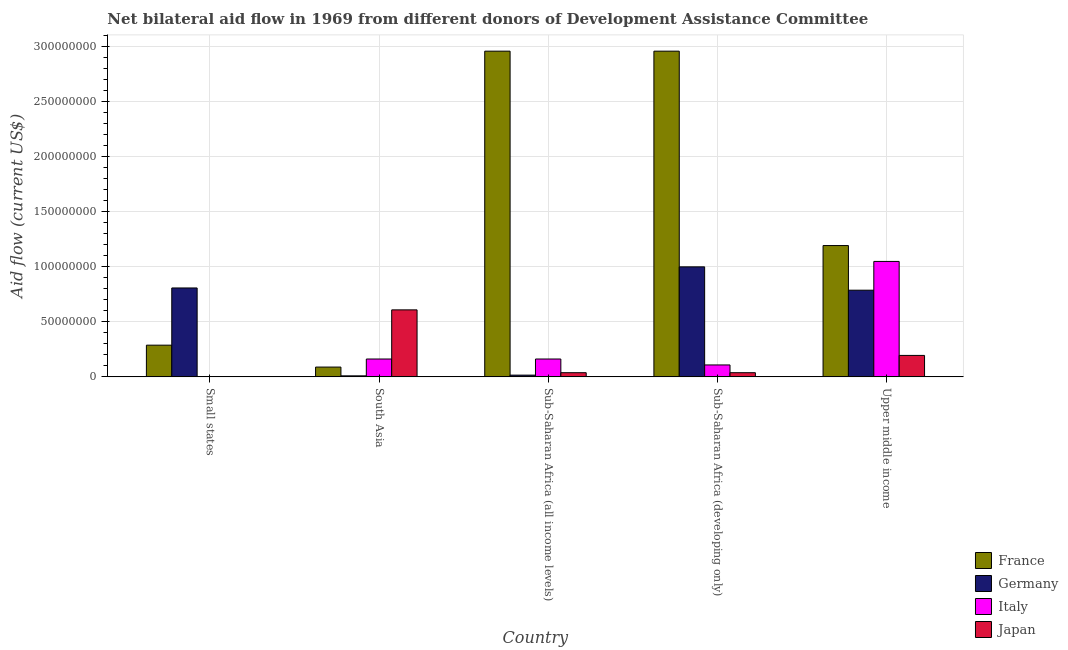How many groups of bars are there?
Ensure brevity in your answer.  5. Are the number of bars on each tick of the X-axis equal?
Your response must be concise. Yes. How many bars are there on the 4th tick from the left?
Give a very brief answer. 4. How many bars are there on the 2nd tick from the right?
Keep it short and to the point. 4. What is the label of the 2nd group of bars from the left?
Your answer should be compact. South Asia. In how many cases, is the number of bars for a given country not equal to the number of legend labels?
Your response must be concise. 0. What is the amount of aid given by germany in Small states?
Ensure brevity in your answer.  8.08e+07. Across all countries, what is the maximum amount of aid given by france?
Offer a very short reply. 2.96e+08. Across all countries, what is the minimum amount of aid given by france?
Your answer should be compact. 8.90e+06. In which country was the amount of aid given by italy maximum?
Make the answer very short. Upper middle income. In which country was the amount of aid given by japan minimum?
Provide a succinct answer. Small states. What is the total amount of aid given by france in the graph?
Provide a short and direct response. 7.49e+08. What is the difference between the amount of aid given by italy in Sub-Saharan Africa (developing only) and that in Upper middle income?
Offer a very short reply. -9.40e+07. What is the difference between the amount of aid given by japan in Small states and the amount of aid given by germany in Sub-Saharan Africa (all income levels)?
Provide a succinct answer. -1.45e+06. What is the average amount of aid given by germany per country?
Your answer should be compact. 5.24e+07. What is the difference between the amount of aid given by japan and amount of aid given by italy in Upper middle income?
Provide a short and direct response. -8.54e+07. What is the ratio of the amount of aid given by germany in Sub-Saharan Africa (all income levels) to that in Sub-Saharan Africa (developing only)?
Give a very brief answer. 0.02. Is the amount of aid given by germany in Sub-Saharan Africa (developing only) less than that in Upper middle income?
Your answer should be compact. No. What is the difference between the highest and the second highest amount of aid given by germany?
Give a very brief answer. 1.92e+07. What is the difference between the highest and the lowest amount of aid given by italy?
Your response must be concise. 1.05e+08. In how many countries, is the amount of aid given by japan greater than the average amount of aid given by japan taken over all countries?
Make the answer very short. 2. Is the sum of the amount of aid given by japan in Sub-Saharan Africa (all income levels) and Upper middle income greater than the maximum amount of aid given by italy across all countries?
Your response must be concise. No. Are the values on the major ticks of Y-axis written in scientific E-notation?
Your response must be concise. No. Does the graph contain any zero values?
Make the answer very short. No. Where does the legend appear in the graph?
Offer a terse response. Bottom right. How many legend labels are there?
Give a very brief answer. 4. What is the title of the graph?
Give a very brief answer. Net bilateral aid flow in 1969 from different donors of Development Assistance Committee. Does "Revenue mobilization" appear as one of the legend labels in the graph?
Make the answer very short. No. What is the label or title of the X-axis?
Your answer should be compact. Country. What is the Aid flow (current US$) in France in Small states?
Give a very brief answer. 2.88e+07. What is the Aid flow (current US$) of Germany in Small states?
Give a very brief answer. 8.08e+07. What is the Aid flow (current US$) of Italy in Small states?
Your answer should be compact. 9.00e+04. What is the Aid flow (current US$) of France in South Asia?
Offer a terse response. 8.90e+06. What is the Aid flow (current US$) in Germany in South Asia?
Offer a terse response. 9.20e+05. What is the Aid flow (current US$) of Italy in South Asia?
Keep it short and to the point. 1.62e+07. What is the Aid flow (current US$) of Japan in South Asia?
Give a very brief answer. 6.09e+07. What is the Aid flow (current US$) in France in Sub-Saharan Africa (all income levels)?
Your answer should be very brief. 2.96e+08. What is the Aid flow (current US$) of Germany in Sub-Saharan Africa (all income levels)?
Make the answer very short. 1.58e+06. What is the Aid flow (current US$) in Italy in Sub-Saharan Africa (all income levels)?
Offer a terse response. 1.62e+07. What is the Aid flow (current US$) of Japan in Sub-Saharan Africa (all income levels)?
Your response must be concise. 3.79e+06. What is the Aid flow (current US$) of France in Sub-Saharan Africa (developing only)?
Offer a very short reply. 2.96e+08. What is the Aid flow (current US$) in Germany in Sub-Saharan Africa (developing only)?
Offer a terse response. 1.00e+08. What is the Aid flow (current US$) of Italy in Sub-Saharan Africa (developing only)?
Offer a terse response. 1.08e+07. What is the Aid flow (current US$) in Japan in Sub-Saharan Africa (developing only)?
Offer a very short reply. 3.79e+06. What is the Aid flow (current US$) in France in Upper middle income?
Provide a short and direct response. 1.19e+08. What is the Aid flow (current US$) of Germany in Upper middle income?
Keep it short and to the point. 7.88e+07. What is the Aid flow (current US$) of Italy in Upper middle income?
Provide a short and direct response. 1.05e+08. What is the Aid flow (current US$) in Japan in Upper middle income?
Offer a terse response. 1.95e+07. Across all countries, what is the maximum Aid flow (current US$) of France?
Offer a terse response. 2.96e+08. Across all countries, what is the maximum Aid flow (current US$) of Germany?
Offer a very short reply. 1.00e+08. Across all countries, what is the maximum Aid flow (current US$) in Italy?
Give a very brief answer. 1.05e+08. Across all countries, what is the maximum Aid flow (current US$) in Japan?
Offer a terse response. 6.09e+07. Across all countries, what is the minimum Aid flow (current US$) in France?
Offer a terse response. 8.90e+06. Across all countries, what is the minimum Aid flow (current US$) in Germany?
Make the answer very short. 9.20e+05. Across all countries, what is the minimum Aid flow (current US$) of Italy?
Your answer should be very brief. 9.00e+04. Across all countries, what is the minimum Aid flow (current US$) in Japan?
Offer a terse response. 1.30e+05. What is the total Aid flow (current US$) in France in the graph?
Your response must be concise. 7.49e+08. What is the total Aid flow (current US$) in Germany in the graph?
Give a very brief answer. 2.62e+08. What is the total Aid flow (current US$) in Italy in the graph?
Your response must be concise. 1.48e+08. What is the total Aid flow (current US$) of Japan in the graph?
Your answer should be compact. 8.81e+07. What is the difference between the Aid flow (current US$) in France in Small states and that in South Asia?
Your response must be concise. 1.99e+07. What is the difference between the Aid flow (current US$) of Germany in Small states and that in South Asia?
Give a very brief answer. 7.98e+07. What is the difference between the Aid flow (current US$) of Italy in Small states and that in South Asia?
Your answer should be compact. -1.61e+07. What is the difference between the Aid flow (current US$) in Japan in Small states and that in South Asia?
Your response must be concise. -6.07e+07. What is the difference between the Aid flow (current US$) in France in Small states and that in Sub-Saharan Africa (all income levels)?
Provide a succinct answer. -2.67e+08. What is the difference between the Aid flow (current US$) of Germany in Small states and that in Sub-Saharan Africa (all income levels)?
Provide a short and direct response. 7.92e+07. What is the difference between the Aid flow (current US$) in Italy in Small states and that in Sub-Saharan Africa (all income levels)?
Give a very brief answer. -1.61e+07. What is the difference between the Aid flow (current US$) of Japan in Small states and that in Sub-Saharan Africa (all income levels)?
Your answer should be compact. -3.66e+06. What is the difference between the Aid flow (current US$) in France in Small states and that in Sub-Saharan Africa (developing only)?
Offer a very short reply. -2.67e+08. What is the difference between the Aid flow (current US$) of Germany in Small states and that in Sub-Saharan Africa (developing only)?
Offer a terse response. -1.92e+07. What is the difference between the Aid flow (current US$) of Italy in Small states and that in Sub-Saharan Africa (developing only)?
Provide a succinct answer. -1.07e+07. What is the difference between the Aid flow (current US$) in Japan in Small states and that in Sub-Saharan Africa (developing only)?
Provide a succinct answer. -3.66e+06. What is the difference between the Aid flow (current US$) in France in Small states and that in Upper middle income?
Provide a succinct answer. -9.05e+07. What is the difference between the Aid flow (current US$) of Germany in Small states and that in Upper middle income?
Ensure brevity in your answer.  2.02e+06. What is the difference between the Aid flow (current US$) of Italy in Small states and that in Upper middle income?
Give a very brief answer. -1.05e+08. What is the difference between the Aid flow (current US$) in Japan in Small states and that in Upper middle income?
Your answer should be compact. -1.94e+07. What is the difference between the Aid flow (current US$) of France in South Asia and that in Sub-Saharan Africa (all income levels)?
Give a very brief answer. -2.87e+08. What is the difference between the Aid flow (current US$) in Germany in South Asia and that in Sub-Saharan Africa (all income levels)?
Provide a short and direct response. -6.60e+05. What is the difference between the Aid flow (current US$) in Japan in South Asia and that in Sub-Saharan Africa (all income levels)?
Make the answer very short. 5.71e+07. What is the difference between the Aid flow (current US$) of France in South Asia and that in Sub-Saharan Africa (developing only)?
Your answer should be very brief. -2.87e+08. What is the difference between the Aid flow (current US$) of Germany in South Asia and that in Sub-Saharan Africa (developing only)?
Your response must be concise. -9.90e+07. What is the difference between the Aid flow (current US$) in Italy in South Asia and that in Sub-Saharan Africa (developing only)?
Your answer should be very brief. 5.40e+06. What is the difference between the Aid flow (current US$) of Japan in South Asia and that in Sub-Saharan Africa (developing only)?
Give a very brief answer. 5.71e+07. What is the difference between the Aid flow (current US$) of France in South Asia and that in Upper middle income?
Keep it short and to the point. -1.10e+08. What is the difference between the Aid flow (current US$) of Germany in South Asia and that in Upper middle income?
Offer a terse response. -7.78e+07. What is the difference between the Aid flow (current US$) in Italy in South Asia and that in Upper middle income?
Provide a short and direct response. -8.86e+07. What is the difference between the Aid flow (current US$) of Japan in South Asia and that in Upper middle income?
Your answer should be compact. 4.14e+07. What is the difference between the Aid flow (current US$) in Germany in Sub-Saharan Africa (all income levels) and that in Sub-Saharan Africa (developing only)?
Offer a very short reply. -9.84e+07. What is the difference between the Aid flow (current US$) of Italy in Sub-Saharan Africa (all income levels) and that in Sub-Saharan Africa (developing only)?
Ensure brevity in your answer.  5.40e+06. What is the difference between the Aid flow (current US$) in Japan in Sub-Saharan Africa (all income levels) and that in Sub-Saharan Africa (developing only)?
Provide a succinct answer. 0. What is the difference between the Aid flow (current US$) in France in Sub-Saharan Africa (all income levels) and that in Upper middle income?
Make the answer very short. 1.77e+08. What is the difference between the Aid flow (current US$) of Germany in Sub-Saharan Africa (all income levels) and that in Upper middle income?
Give a very brief answer. -7.72e+07. What is the difference between the Aid flow (current US$) of Italy in Sub-Saharan Africa (all income levels) and that in Upper middle income?
Your answer should be very brief. -8.86e+07. What is the difference between the Aid flow (current US$) of Japan in Sub-Saharan Africa (all income levels) and that in Upper middle income?
Provide a succinct answer. -1.57e+07. What is the difference between the Aid flow (current US$) of France in Sub-Saharan Africa (developing only) and that in Upper middle income?
Ensure brevity in your answer.  1.77e+08. What is the difference between the Aid flow (current US$) of Germany in Sub-Saharan Africa (developing only) and that in Upper middle income?
Ensure brevity in your answer.  2.12e+07. What is the difference between the Aid flow (current US$) in Italy in Sub-Saharan Africa (developing only) and that in Upper middle income?
Your answer should be very brief. -9.40e+07. What is the difference between the Aid flow (current US$) in Japan in Sub-Saharan Africa (developing only) and that in Upper middle income?
Make the answer very short. -1.57e+07. What is the difference between the Aid flow (current US$) in France in Small states and the Aid flow (current US$) in Germany in South Asia?
Offer a terse response. 2.79e+07. What is the difference between the Aid flow (current US$) of France in Small states and the Aid flow (current US$) of Italy in South Asia?
Make the answer very short. 1.26e+07. What is the difference between the Aid flow (current US$) of France in Small states and the Aid flow (current US$) of Japan in South Asia?
Give a very brief answer. -3.21e+07. What is the difference between the Aid flow (current US$) of Germany in Small states and the Aid flow (current US$) of Italy in South Asia?
Provide a succinct answer. 6.45e+07. What is the difference between the Aid flow (current US$) of Germany in Small states and the Aid flow (current US$) of Japan in South Asia?
Ensure brevity in your answer.  1.99e+07. What is the difference between the Aid flow (current US$) of Italy in Small states and the Aid flow (current US$) of Japan in South Asia?
Keep it short and to the point. -6.08e+07. What is the difference between the Aid flow (current US$) in France in Small states and the Aid flow (current US$) in Germany in Sub-Saharan Africa (all income levels)?
Keep it short and to the point. 2.72e+07. What is the difference between the Aid flow (current US$) of France in Small states and the Aid flow (current US$) of Italy in Sub-Saharan Africa (all income levels)?
Your answer should be very brief. 1.26e+07. What is the difference between the Aid flow (current US$) in France in Small states and the Aid flow (current US$) in Japan in Sub-Saharan Africa (all income levels)?
Ensure brevity in your answer.  2.50e+07. What is the difference between the Aid flow (current US$) of Germany in Small states and the Aid flow (current US$) of Italy in Sub-Saharan Africa (all income levels)?
Offer a terse response. 6.45e+07. What is the difference between the Aid flow (current US$) of Germany in Small states and the Aid flow (current US$) of Japan in Sub-Saharan Africa (all income levels)?
Give a very brief answer. 7.70e+07. What is the difference between the Aid flow (current US$) in Italy in Small states and the Aid flow (current US$) in Japan in Sub-Saharan Africa (all income levels)?
Your answer should be very brief. -3.70e+06. What is the difference between the Aid flow (current US$) in France in Small states and the Aid flow (current US$) in Germany in Sub-Saharan Africa (developing only)?
Your answer should be very brief. -7.12e+07. What is the difference between the Aid flow (current US$) of France in Small states and the Aid flow (current US$) of Italy in Sub-Saharan Africa (developing only)?
Make the answer very short. 1.80e+07. What is the difference between the Aid flow (current US$) of France in Small states and the Aid flow (current US$) of Japan in Sub-Saharan Africa (developing only)?
Make the answer very short. 2.50e+07. What is the difference between the Aid flow (current US$) in Germany in Small states and the Aid flow (current US$) in Italy in Sub-Saharan Africa (developing only)?
Provide a succinct answer. 6.99e+07. What is the difference between the Aid flow (current US$) in Germany in Small states and the Aid flow (current US$) in Japan in Sub-Saharan Africa (developing only)?
Give a very brief answer. 7.70e+07. What is the difference between the Aid flow (current US$) of Italy in Small states and the Aid flow (current US$) of Japan in Sub-Saharan Africa (developing only)?
Ensure brevity in your answer.  -3.70e+06. What is the difference between the Aid flow (current US$) of France in Small states and the Aid flow (current US$) of Germany in Upper middle income?
Make the answer very short. -5.00e+07. What is the difference between the Aid flow (current US$) in France in Small states and the Aid flow (current US$) in Italy in Upper middle income?
Keep it short and to the point. -7.61e+07. What is the difference between the Aid flow (current US$) in France in Small states and the Aid flow (current US$) in Japan in Upper middle income?
Your answer should be compact. 9.31e+06. What is the difference between the Aid flow (current US$) in Germany in Small states and the Aid flow (current US$) in Italy in Upper middle income?
Provide a succinct answer. -2.41e+07. What is the difference between the Aid flow (current US$) in Germany in Small states and the Aid flow (current US$) in Japan in Upper middle income?
Provide a succinct answer. 6.13e+07. What is the difference between the Aid flow (current US$) in Italy in Small states and the Aid flow (current US$) in Japan in Upper middle income?
Make the answer very short. -1.94e+07. What is the difference between the Aid flow (current US$) in France in South Asia and the Aid flow (current US$) in Germany in Sub-Saharan Africa (all income levels)?
Your response must be concise. 7.32e+06. What is the difference between the Aid flow (current US$) of France in South Asia and the Aid flow (current US$) of Italy in Sub-Saharan Africa (all income levels)?
Offer a very short reply. -7.33e+06. What is the difference between the Aid flow (current US$) in France in South Asia and the Aid flow (current US$) in Japan in Sub-Saharan Africa (all income levels)?
Your response must be concise. 5.11e+06. What is the difference between the Aid flow (current US$) of Germany in South Asia and the Aid flow (current US$) of Italy in Sub-Saharan Africa (all income levels)?
Offer a terse response. -1.53e+07. What is the difference between the Aid flow (current US$) of Germany in South Asia and the Aid flow (current US$) of Japan in Sub-Saharan Africa (all income levels)?
Keep it short and to the point. -2.87e+06. What is the difference between the Aid flow (current US$) in Italy in South Asia and the Aid flow (current US$) in Japan in Sub-Saharan Africa (all income levels)?
Give a very brief answer. 1.24e+07. What is the difference between the Aid flow (current US$) of France in South Asia and the Aid flow (current US$) of Germany in Sub-Saharan Africa (developing only)?
Provide a short and direct response. -9.10e+07. What is the difference between the Aid flow (current US$) of France in South Asia and the Aid flow (current US$) of Italy in Sub-Saharan Africa (developing only)?
Your answer should be very brief. -1.93e+06. What is the difference between the Aid flow (current US$) of France in South Asia and the Aid flow (current US$) of Japan in Sub-Saharan Africa (developing only)?
Provide a succinct answer. 5.11e+06. What is the difference between the Aid flow (current US$) in Germany in South Asia and the Aid flow (current US$) in Italy in Sub-Saharan Africa (developing only)?
Your answer should be compact. -9.91e+06. What is the difference between the Aid flow (current US$) in Germany in South Asia and the Aid flow (current US$) in Japan in Sub-Saharan Africa (developing only)?
Make the answer very short. -2.87e+06. What is the difference between the Aid flow (current US$) of Italy in South Asia and the Aid flow (current US$) of Japan in Sub-Saharan Africa (developing only)?
Offer a terse response. 1.24e+07. What is the difference between the Aid flow (current US$) in France in South Asia and the Aid flow (current US$) in Germany in Upper middle income?
Provide a short and direct response. -6.98e+07. What is the difference between the Aid flow (current US$) of France in South Asia and the Aid flow (current US$) of Italy in Upper middle income?
Give a very brief answer. -9.60e+07. What is the difference between the Aid flow (current US$) of France in South Asia and the Aid flow (current US$) of Japan in Upper middle income?
Provide a succinct answer. -1.06e+07. What is the difference between the Aid flow (current US$) in Germany in South Asia and the Aid flow (current US$) in Italy in Upper middle income?
Offer a very short reply. -1.04e+08. What is the difference between the Aid flow (current US$) of Germany in South Asia and the Aid flow (current US$) of Japan in Upper middle income?
Provide a succinct answer. -1.86e+07. What is the difference between the Aid flow (current US$) in Italy in South Asia and the Aid flow (current US$) in Japan in Upper middle income?
Your answer should be very brief. -3.26e+06. What is the difference between the Aid flow (current US$) in France in Sub-Saharan Africa (all income levels) and the Aid flow (current US$) in Germany in Sub-Saharan Africa (developing only)?
Make the answer very short. 1.96e+08. What is the difference between the Aid flow (current US$) in France in Sub-Saharan Africa (all income levels) and the Aid flow (current US$) in Italy in Sub-Saharan Africa (developing only)?
Your answer should be compact. 2.85e+08. What is the difference between the Aid flow (current US$) of France in Sub-Saharan Africa (all income levels) and the Aid flow (current US$) of Japan in Sub-Saharan Africa (developing only)?
Keep it short and to the point. 2.92e+08. What is the difference between the Aid flow (current US$) in Germany in Sub-Saharan Africa (all income levels) and the Aid flow (current US$) in Italy in Sub-Saharan Africa (developing only)?
Your answer should be compact. -9.25e+06. What is the difference between the Aid flow (current US$) in Germany in Sub-Saharan Africa (all income levels) and the Aid flow (current US$) in Japan in Sub-Saharan Africa (developing only)?
Give a very brief answer. -2.21e+06. What is the difference between the Aid flow (current US$) of Italy in Sub-Saharan Africa (all income levels) and the Aid flow (current US$) of Japan in Sub-Saharan Africa (developing only)?
Your answer should be compact. 1.24e+07. What is the difference between the Aid flow (current US$) of France in Sub-Saharan Africa (all income levels) and the Aid flow (current US$) of Germany in Upper middle income?
Provide a succinct answer. 2.17e+08. What is the difference between the Aid flow (current US$) in France in Sub-Saharan Africa (all income levels) and the Aid flow (current US$) in Italy in Upper middle income?
Your answer should be very brief. 1.91e+08. What is the difference between the Aid flow (current US$) of France in Sub-Saharan Africa (all income levels) and the Aid flow (current US$) of Japan in Upper middle income?
Your answer should be compact. 2.76e+08. What is the difference between the Aid flow (current US$) in Germany in Sub-Saharan Africa (all income levels) and the Aid flow (current US$) in Italy in Upper middle income?
Offer a very short reply. -1.03e+08. What is the difference between the Aid flow (current US$) of Germany in Sub-Saharan Africa (all income levels) and the Aid flow (current US$) of Japan in Upper middle income?
Offer a very short reply. -1.79e+07. What is the difference between the Aid flow (current US$) of Italy in Sub-Saharan Africa (all income levels) and the Aid flow (current US$) of Japan in Upper middle income?
Your response must be concise. -3.26e+06. What is the difference between the Aid flow (current US$) in France in Sub-Saharan Africa (developing only) and the Aid flow (current US$) in Germany in Upper middle income?
Your response must be concise. 2.17e+08. What is the difference between the Aid flow (current US$) of France in Sub-Saharan Africa (developing only) and the Aid flow (current US$) of Italy in Upper middle income?
Provide a succinct answer. 1.91e+08. What is the difference between the Aid flow (current US$) of France in Sub-Saharan Africa (developing only) and the Aid flow (current US$) of Japan in Upper middle income?
Your answer should be compact. 2.76e+08. What is the difference between the Aid flow (current US$) in Germany in Sub-Saharan Africa (developing only) and the Aid flow (current US$) in Italy in Upper middle income?
Give a very brief answer. -4.92e+06. What is the difference between the Aid flow (current US$) of Germany in Sub-Saharan Africa (developing only) and the Aid flow (current US$) of Japan in Upper middle income?
Offer a very short reply. 8.05e+07. What is the difference between the Aid flow (current US$) of Italy in Sub-Saharan Africa (developing only) and the Aid flow (current US$) of Japan in Upper middle income?
Your answer should be compact. -8.66e+06. What is the average Aid flow (current US$) in France per country?
Provide a succinct answer. 1.50e+08. What is the average Aid flow (current US$) in Germany per country?
Keep it short and to the point. 5.24e+07. What is the average Aid flow (current US$) of Italy per country?
Your answer should be very brief. 2.96e+07. What is the average Aid flow (current US$) in Japan per country?
Give a very brief answer. 1.76e+07. What is the difference between the Aid flow (current US$) in France and Aid flow (current US$) in Germany in Small states?
Your response must be concise. -5.20e+07. What is the difference between the Aid flow (current US$) in France and Aid flow (current US$) in Italy in Small states?
Offer a terse response. 2.87e+07. What is the difference between the Aid flow (current US$) in France and Aid flow (current US$) in Japan in Small states?
Offer a terse response. 2.87e+07. What is the difference between the Aid flow (current US$) in Germany and Aid flow (current US$) in Italy in Small states?
Provide a succinct answer. 8.07e+07. What is the difference between the Aid flow (current US$) in Germany and Aid flow (current US$) in Japan in Small states?
Your response must be concise. 8.06e+07. What is the difference between the Aid flow (current US$) of Italy and Aid flow (current US$) of Japan in Small states?
Give a very brief answer. -4.00e+04. What is the difference between the Aid flow (current US$) in France and Aid flow (current US$) in Germany in South Asia?
Provide a succinct answer. 7.98e+06. What is the difference between the Aid flow (current US$) in France and Aid flow (current US$) in Italy in South Asia?
Offer a very short reply. -7.33e+06. What is the difference between the Aid flow (current US$) of France and Aid flow (current US$) of Japan in South Asia?
Provide a succinct answer. -5.20e+07. What is the difference between the Aid flow (current US$) in Germany and Aid flow (current US$) in Italy in South Asia?
Keep it short and to the point. -1.53e+07. What is the difference between the Aid flow (current US$) of Germany and Aid flow (current US$) of Japan in South Asia?
Offer a very short reply. -6.00e+07. What is the difference between the Aid flow (current US$) in Italy and Aid flow (current US$) in Japan in South Asia?
Your answer should be very brief. -4.46e+07. What is the difference between the Aid flow (current US$) in France and Aid flow (current US$) in Germany in Sub-Saharan Africa (all income levels)?
Your answer should be very brief. 2.94e+08. What is the difference between the Aid flow (current US$) in France and Aid flow (current US$) in Italy in Sub-Saharan Africa (all income levels)?
Give a very brief answer. 2.80e+08. What is the difference between the Aid flow (current US$) in France and Aid flow (current US$) in Japan in Sub-Saharan Africa (all income levels)?
Your response must be concise. 2.92e+08. What is the difference between the Aid flow (current US$) of Germany and Aid flow (current US$) of Italy in Sub-Saharan Africa (all income levels)?
Keep it short and to the point. -1.46e+07. What is the difference between the Aid flow (current US$) in Germany and Aid flow (current US$) in Japan in Sub-Saharan Africa (all income levels)?
Ensure brevity in your answer.  -2.21e+06. What is the difference between the Aid flow (current US$) in Italy and Aid flow (current US$) in Japan in Sub-Saharan Africa (all income levels)?
Provide a succinct answer. 1.24e+07. What is the difference between the Aid flow (current US$) of France and Aid flow (current US$) of Germany in Sub-Saharan Africa (developing only)?
Provide a succinct answer. 1.96e+08. What is the difference between the Aid flow (current US$) in France and Aid flow (current US$) in Italy in Sub-Saharan Africa (developing only)?
Keep it short and to the point. 2.85e+08. What is the difference between the Aid flow (current US$) of France and Aid flow (current US$) of Japan in Sub-Saharan Africa (developing only)?
Your answer should be compact. 2.92e+08. What is the difference between the Aid flow (current US$) in Germany and Aid flow (current US$) in Italy in Sub-Saharan Africa (developing only)?
Your answer should be compact. 8.91e+07. What is the difference between the Aid flow (current US$) of Germany and Aid flow (current US$) of Japan in Sub-Saharan Africa (developing only)?
Offer a terse response. 9.62e+07. What is the difference between the Aid flow (current US$) of Italy and Aid flow (current US$) of Japan in Sub-Saharan Africa (developing only)?
Provide a short and direct response. 7.04e+06. What is the difference between the Aid flow (current US$) in France and Aid flow (current US$) in Germany in Upper middle income?
Your answer should be very brief. 4.06e+07. What is the difference between the Aid flow (current US$) in France and Aid flow (current US$) in Italy in Upper middle income?
Make the answer very short. 1.44e+07. What is the difference between the Aid flow (current US$) in France and Aid flow (current US$) in Japan in Upper middle income?
Offer a very short reply. 9.98e+07. What is the difference between the Aid flow (current US$) in Germany and Aid flow (current US$) in Italy in Upper middle income?
Provide a succinct answer. -2.61e+07. What is the difference between the Aid flow (current US$) in Germany and Aid flow (current US$) in Japan in Upper middle income?
Your answer should be very brief. 5.93e+07. What is the difference between the Aid flow (current US$) in Italy and Aid flow (current US$) in Japan in Upper middle income?
Your answer should be very brief. 8.54e+07. What is the ratio of the Aid flow (current US$) of France in Small states to that in South Asia?
Your response must be concise. 3.24. What is the ratio of the Aid flow (current US$) of Germany in Small states to that in South Asia?
Offer a very short reply. 87.79. What is the ratio of the Aid flow (current US$) of Italy in Small states to that in South Asia?
Keep it short and to the point. 0.01. What is the ratio of the Aid flow (current US$) in Japan in Small states to that in South Asia?
Offer a very short reply. 0. What is the ratio of the Aid flow (current US$) in France in Small states to that in Sub-Saharan Africa (all income levels)?
Your response must be concise. 0.1. What is the ratio of the Aid flow (current US$) in Germany in Small states to that in Sub-Saharan Africa (all income levels)?
Your answer should be very brief. 51.12. What is the ratio of the Aid flow (current US$) of Italy in Small states to that in Sub-Saharan Africa (all income levels)?
Provide a succinct answer. 0.01. What is the ratio of the Aid flow (current US$) of Japan in Small states to that in Sub-Saharan Africa (all income levels)?
Your response must be concise. 0.03. What is the ratio of the Aid flow (current US$) in France in Small states to that in Sub-Saharan Africa (developing only)?
Provide a short and direct response. 0.1. What is the ratio of the Aid flow (current US$) of Germany in Small states to that in Sub-Saharan Africa (developing only)?
Ensure brevity in your answer.  0.81. What is the ratio of the Aid flow (current US$) in Italy in Small states to that in Sub-Saharan Africa (developing only)?
Provide a short and direct response. 0.01. What is the ratio of the Aid flow (current US$) of Japan in Small states to that in Sub-Saharan Africa (developing only)?
Ensure brevity in your answer.  0.03. What is the ratio of the Aid flow (current US$) in France in Small states to that in Upper middle income?
Provide a succinct answer. 0.24. What is the ratio of the Aid flow (current US$) of Germany in Small states to that in Upper middle income?
Keep it short and to the point. 1.03. What is the ratio of the Aid flow (current US$) in Italy in Small states to that in Upper middle income?
Provide a short and direct response. 0. What is the ratio of the Aid flow (current US$) in Japan in Small states to that in Upper middle income?
Offer a very short reply. 0.01. What is the ratio of the Aid flow (current US$) of France in South Asia to that in Sub-Saharan Africa (all income levels)?
Provide a succinct answer. 0.03. What is the ratio of the Aid flow (current US$) in Germany in South Asia to that in Sub-Saharan Africa (all income levels)?
Offer a terse response. 0.58. What is the ratio of the Aid flow (current US$) of Japan in South Asia to that in Sub-Saharan Africa (all income levels)?
Your response must be concise. 16.06. What is the ratio of the Aid flow (current US$) of France in South Asia to that in Sub-Saharan Africa (developing only)?
Keep it short and to the point. 0.03. What is the ratio of the Aid flow (current US$) in Germany in South Asia to that in Sub-Saharan Africa (developing only)?
Keep it short and to the point. 0.01. What is the ratio of the Aid flow (current US$) of Italy in South Asia to that in Sub-Saharan Africa (developing only)?
Your answer should be compact. 1.5. What is the ratio of the Aid flow (current US$) of Japan in South Asia to that in Sub-Saharan Africa (developing only)?
Your answer should be compact. 16.06. What is the ratio of the Aid flow (current US$) of France in South Asia to that in Upper middle income?
Give a very brief answer. 0.07. What is the ratio of the Aid flow (current US$) in Germany in South Asia to that in Upper middle income?
Provide a short and direct response. 0.01. What is the ratio of the Aid flow (current US$) of Italy in South Asia to that in Upper middle income?
Provide a succinct answer. 0.15. What is the ratio of the Aid flow (current US$) in Japan in South Asia to that in Upper middle income?
Your answer should be very brief. 3.12. What is the ratio of the Aid flow (current US$) of France in Sub-Saharan Africa (all income levels) to that in Sub-Saharan Africa (developing only)?
Your answer should be very brief. 1. What is the ratio of the Aid flow (current US$) of Germany in Sub-Saharan Africa (all income levels) to that in Sub-Saharan Africa (developing only)?
Your answer should be compact. 0.02. What is the ratio of the Aid flow (current US$) of Italy in Sub-Saharan Africa (all income levels) to that in Sub-Saharan Africa (developing only)?
Offer a very short reply. 1.5. What is the ratio of the Aid flow (current US$) in France in Sub-Saharan Africa (all income levels) to that in Upper middle income?
Provide a short and direct response. 2.48. What is the ratio of the Aid flow (current US$) of Germany in Sub-Saharan Africa (all income levels) to that in Upper middle income?
Ensure brevity in your answer.  0.02. What is the ratio of the Aid flow (current US$) in Italy in Sub-Saharan Africa (all income levels) to that in Upper middle income?
Make the answer very short. 0.15. What is the ratio of the Aid flow (current US$) in Japan in Sub-Saharan Africa (all income levels) to that in Upper middle income?
Make the answer very short. 0.19. What is the ratio of the Aid flow (current US$) in France in Sub-Saharan Africa (developing only) to that in Upper middle income?
Offer a very short reply. 2.48. What is the ratio of the Aid flow (current US$) of Germany in Sub-Saharan Africa (developing only) to that in Upper middle income?
Provide a succinct answer. 1.27. What is the ratio of the Aid flow (current US$) in Italy in Sub-Saharan Africa (developing only) to that in Upper middle income?
Keep it short and to the point. 0.1. What is the ratio of the Aid flow (current US$) in Japan in Sub-Saharan Africa (developing only) to that in Upper middle income?
Offer a terse response. 0.19. What is the difference between the highest and the second highest Aid flow (current US$) of Germany?
Offer a very short reply. 1.92e+07. What is the difference between the highest and the second highest Aid flow (current US$) in Italy?
Ensure brevity in your answer.  8.86e+07. What is the difference between the highest and the second highest Aid flow (current US$) in Japan?
Keep it short and to the point. 4.14e+07. What is the difference between the highest and the lowest Aid flow (current US$) in France?
Give a very brief answer. 2.87e+08. What is the difference between the highest and the lowest Aid flow (current US$) in Germany?
Ensure brevity in your answer.  9.90e+07. What is the difference between the highest and the lowest Aid flow (current US$) in Italy?
Your answer should be compact. 1.05e+08. What is the difference between the highest and the lowest Aid flow (current US$) in Japan?
Your answer should be compact. 6.07e+07. 